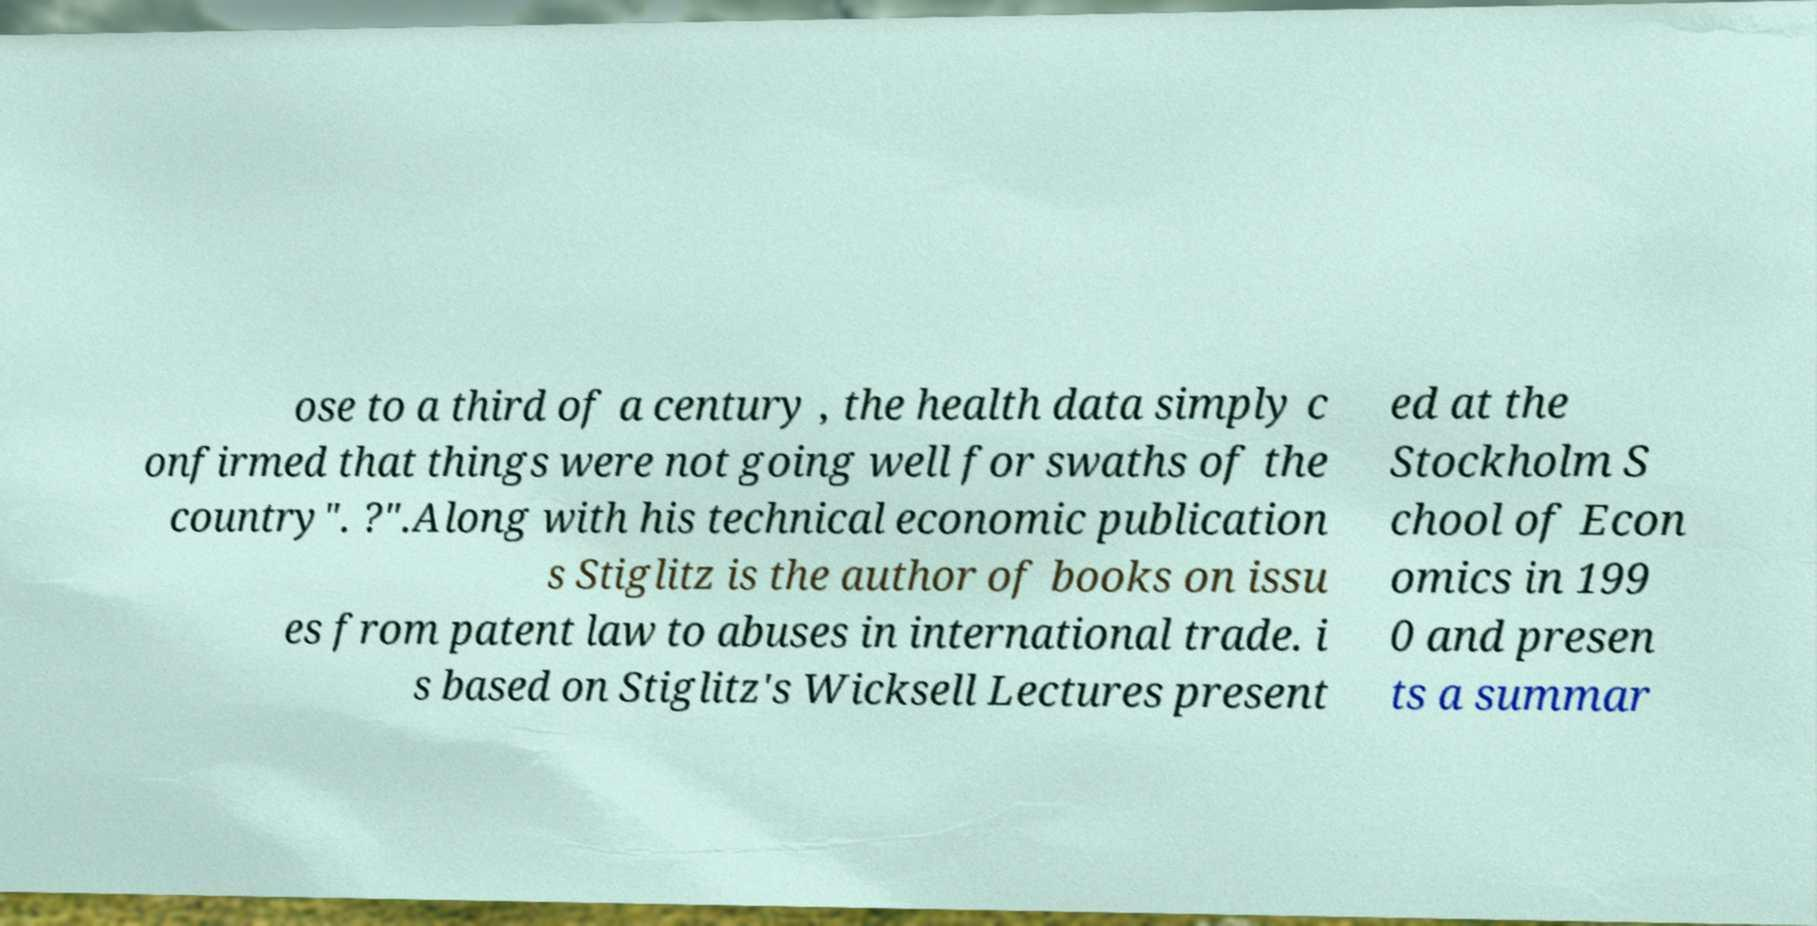Can you read and provide the text displayed in the image?This photo seems to have some interesting text. Can you extract and type it out for me? ose to a third of a century , the health data simply c onfirmed that things were not going well for swaths of the country". ?".Along with his technical economic publication s Stiglitz is the author of books on issu es from patent law to abuses in international trade. i s based on Stiglitz's Wicksell Lectures present ed at the Stockholm S chool of Econ omics in 199 0 and presen ts a summar 